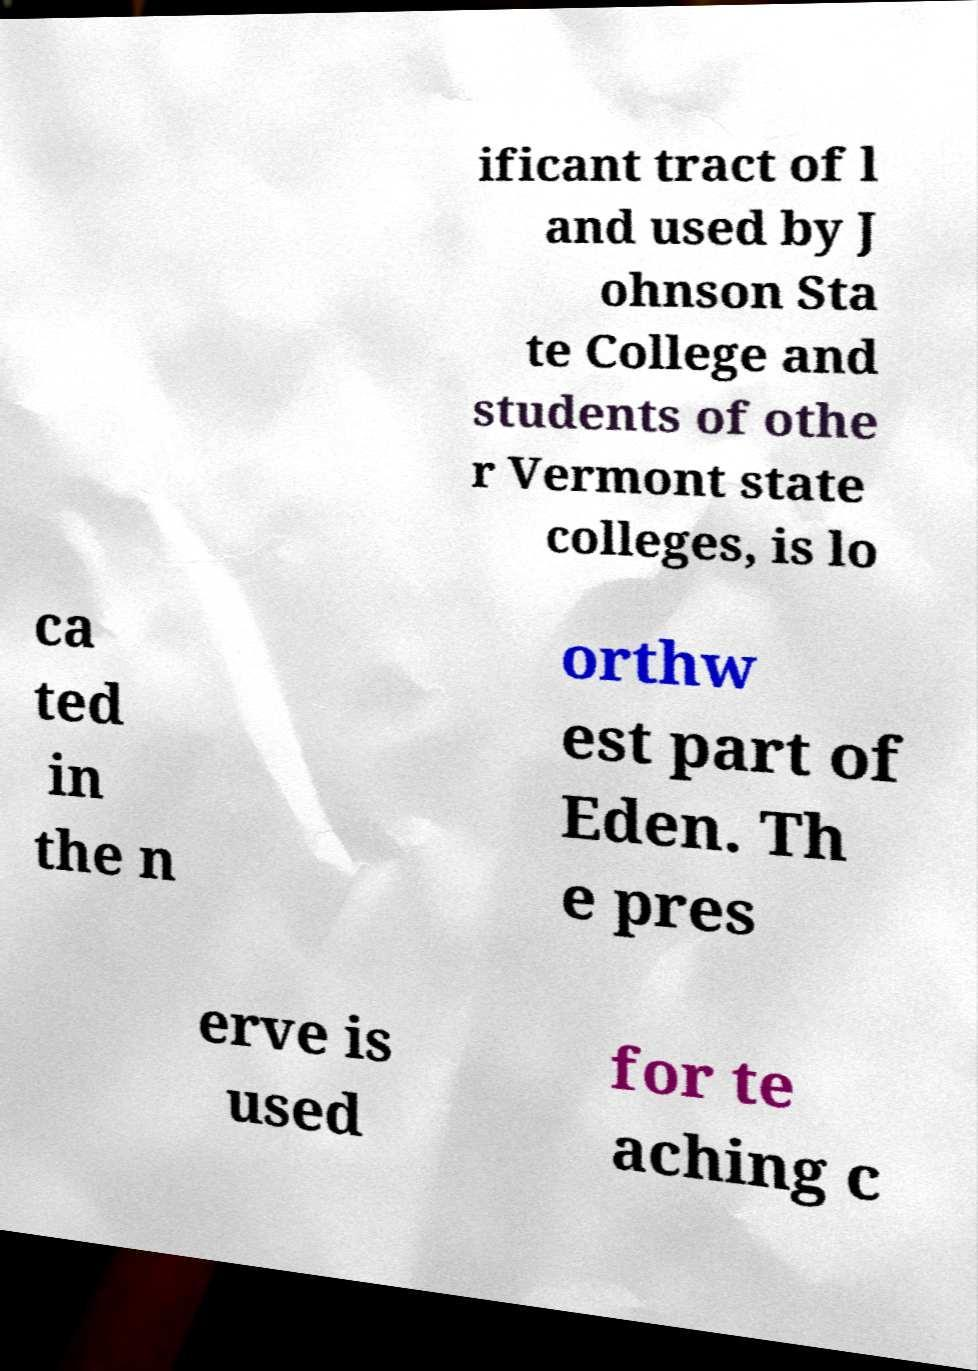Please identify and transcribe the text found in this image. ificant tract of l and used by J ohnson Sta te College and students of othe r Vermont state colleges, is lo ca ted in the n orthw est part of Eden. Th e pres erve is used for te aching c 